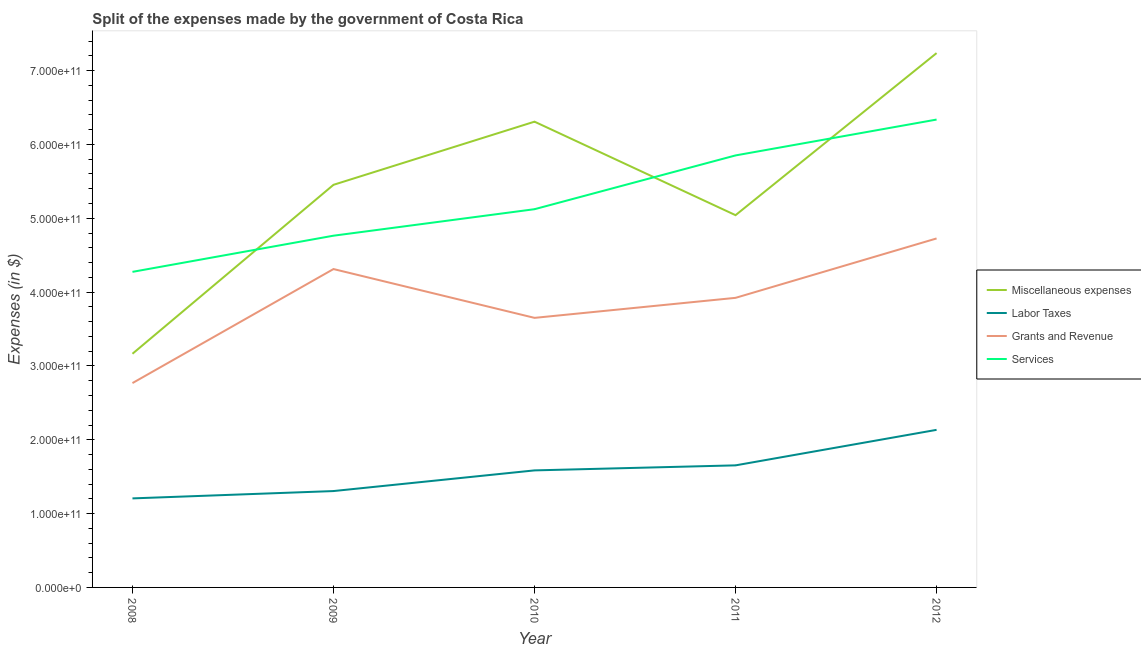How many different coloured lines are there?
Make the answer very short. 4. Is the number of lines equal to the number of legend labels?
Give a very brief answer. Yes. What is the amount spent on grants and revenue in 2012?
Your response must be concise. 4.73e+11. Across all years, what is the maximum amount spent on grants and revenue?
Your answer should be compact. 4.73e+11. Across all years, what is the minimum amount spent on labor taxes?
Offer a terse response. 1.21e+11. In which year was the amount spent on miscellaneous expenses minimum?
Provide a short and direct response. 2008. What is the total amount spent on grants and revenue in the graph?
Offer a terse response. 1.94e+12. What is the difference between the amount spent on miscellaneous expenses in 2011 and that in 2012?
Your answer should be compact. -2.20e+11. What is the difference between the amount spent on labor taxes in 2012 and the amount spent on services in 2010?
Your answer should be compact. -2.99e+11. What is the average amount spent on labor taxes per year?
Ensure brevity in your answer.  1.58e+11. In the year 2008, what is the difference between the amount spent on grants and revenue and amount spent on services?
Ensure brevity in your answer.  -1.51e+11. In how many years, is the amount spent on services greater than 500000000000 $?
Offer a very short reply. 3. What is the ratio of the amount spent on services in 2009 to that in 2011?
Keep it short and to the point. 0.81. Is the amount spent on services in 2009 less than that in 2010?
Offer a terse response. Yes. Is the difference between the amount spent on miscellaneous expenses in 2010 and 2012 greater than the difference between the amount spent on services in 2010 and 2012?
Offer a terse response. Yes. What is the difference between the highest and the second highest amount spent on services?
Provide a succinct answer. 4.86e+1. What is the difference between the highest and the lowest amount spent on services?
Keep it short and to the point. 2.06e+11. In how many years, is the amount spent on miscellaneous expenses greater than the average amount spent on miscellaneous expenses taken over all years?
Provide a short and direct response. 3. Is it the case that in every year, the sum of the amount spent on miscellaneous expenses and amount spent on labor taxes is greater than the amount spent on grants and revenue?
Provide a succinct answer. Yes. Is the amount spent on miscellaneous expenses strictly greater than the amount spent on grants and revenue over the years?
Offer a terse response. Yes. Is the amount spent on miscellaneous expenses strictly less than the amount spent on grants and revenue over the years?
Your answer should be very brief. No. How many lines are there?
Provide a succinct answer. 4. How many years are there in the graph?
Ensure brevity in your answer.  5. What is the difference between two consecutive major ticks on the Y-axis?
Make the answer very short. 1.00e+11. Does the graph contain any zero values?
Provide a short and direct response. No. Does the graph contain grids?
Provide a short and direct response. No. How are the legend labels stacked?
Your answer should be compact. Vertical. What is the title of the graph?
Your answer should be compact. Split of the expenses made by the government of Costa Rica. Does "HFC gas" appear as one of the legend labels in the graph?
Offer a terse response. No. What is the label or title of the Y-axis?
Provide a succinct answer. Expenses (in $). What is the Expenses (in $) in Miscellaneous expenses in 2008?
Your answer should be very brief. 3.16e+11. What is the Expenses (in $) of Labor Taxes in 2008?
Give a very brief answer. 1.21e+11. What is the Expenses (in $) in Grants and Revenue in 2008?
Keep it short and to the point. 2.77e+11. What is the Expenses (in $) in Services in 2008?
Provide a succinct answer. 4.27e+11. What is the Expenses (in $) in Miscellaneous expenses in 2009?
Provide a short and direct response. 5.45e+11. What is the Expenses (in $) of Labor Taxes in 2009?
Keep it short and to the point. 1.31e+11. What is the Expenses (in $) of Grants and Revenue in 2009?
Give a very brief answer. 4.31e+11. What is the Expenses (in $) of Services in 2009?
Your response must be concise. 4.76e+11. What is the Expenses (in $) in Miscellaneous expenses in 2010?
Make the answer very short. 6.31e+11. What is the Expenses (in $) of Labor Taxes in 2010?
Your response must be concise. 1.59e+11. What is the Expenses (in $) in Grants and Revenue in 2010?
Ensure brevity in your answer.  3.65e+11. What is the Expenses (in $) of Services in 2010?
Your answer should be very brief. 5.12e+11. What is the Expenses (in $) of Miscellaneous expenses in 2011?
Your answer should be compact. 5.04e+11. What is the Expenses (in $) of Labor Taxes in 2011?
Your answer should be very brief. 1.65e+11. What is the Expenses (in $) in Grants and Revenue in 2011?
Your answer should be very brief. 3.92e+11. What is the Expenses (in $) of Services in 2011?
Give a very brief answer. 5.85e+11. What is the Expenses (in $) in Miscellaneous expenses in 2012?
Ensure brevity in your answer.  7.24e+11. What is the Expenses (in $) in Labor Taxes in 2012?
Your response must be concise. 2.13e+11. What is the Expenses (in $) of Grants and Revenue in 2012?
Your answer should be compact. 4.73e+11. What is the Expenses (in $) of Services in 2012?
Give a very brief answer. 6.34e+11. Across all years, what is the maximum Expenses (in $) in Miscellaneous expenses?
Provide a short and direct response. 7.24e+11. Across all years, what is the maximum Expenses (in $) of Labor Taxes?
Your response must be concise. 2.13e+11. Across all years, what is the maximum Expenses (in $) of Grants and Revenue?
Your answer should be very brief. 4.73e+11. Across all years, what is the maximum Expenses (in $) of Services?
Give a very brief answer. 6.34e+11. Across all years, what is the minimum Expenses (in $) in Miscellaneous expenses?
Ensure brevity in your answer.  3.16e+11. Across all years, what is the minimum Expenses (in $) in Labor Taxes?
Provide a short and direct response. 1.21e+11. Across all years, what is the minimum Expenses (in $) in Grants and Revenue?
Offer a very short reply. 2.77e+11. Across all years, what is the minimum Expenses (in $) in Services?
Offer a terse response. 4.27e+11. What is the total Expenses (in $) in Miscellaneous expenses in the graph?
Your answer should be very brief. 2.72e+12. What is the total Expenses (in $) of Labor Taxes in the graph?
Make the answer very short. 7.88e+11. What is the total Expenses (in $) in Grants and Revenue in the graph?
Offer a very short reply. 1.94e+12. What is the total Expenses (in $) in Services in the graph?
Keep it short and to the point. 2.63e+12. What is the difference between the Expenses (in $) of Miscellaneous expenses in 2008 and that in 2009?
Offer a very short reply. -2.29e+11. What is the difference between the Expenses (in $) in Labor Taxes in 2008 and that in 2009?
Keep it short and to the point. -9.94e+09. What is the difference between the Expenses (in $) in Grants and Revenue in 2008 and that in 2009?
Offer a terse response. -1.54e+11. What is the difference between the Expenses (in $) of Services in 2008 and that in 2009?
Your answer should be very brief. -4.90e+1. What is the difference between the Expenses (in $) of Miscellaneous expenses in 2008 and that in 2010?
Provide a short and direct response. -3.14e+11. What is the difference between the Expenses (in $) of Labor Taxes in 2008 and that in 2010?
Your answer should be compact. -3.79e+1. What is the difference between the Expenses (in $) of Grants and Revenue in 2008 and that in 2010?
Your response must be concise. -8.83e+1. What is the difference between the Expenses (in $) in Services in 2008 and that in 2010?
Offer a very short reply. -8.49e+1. What is the difference between the Expenses (in $) in Miscellaneous expenses in 2008 and that in 2011?
Make the answer very short. -1.88e+11. What is the difference between the Expenses (in $) of Labor Taxes in 2008 and that in 2011?
Provide a succinct answer. -4.47e+1. What is the difference between the Expenses (in $) in Grants and Revenue in 2008 and that in 2011?
Your answer should be very brief. -1.15e+11. What is the difference between the Expenses (in $) in Services in 2008 and that in 2011?
Give a very brief answer. -1.58e+11. What is the difference between the Expenses (in $) of Miscellaneous expenses in 2008 and that in 2012?
Give a very brief answer. -4.07e+11. What is the difference between the Expenses (in $) in Labor Taxes in 2008 and that in 2012?
Your response must be concise. -9.28e+1. What is the difference between the Expenses (in $) in Grants and Revenue in 2008 and that in 2012?
Your answer should be very brief. -1.96e+11. What is the difference between the Expenses (in $) of Services in 2008 and that in 2012?
Ensure brevity in your answer.  -2.06e+11. What is the difference between the Expenses (in $) of Miscellaneous expenses in 2009 and that in 2010?
Keep it short and to the point. -8.55e+1. What is the difference between the Expenses (in $) of Labor Taxes in 2009 and that in 2010?
Provide a succinct answer. -2.80e+1. What is the difference between the Expenses (in $) of Grants and Revenue in 2009 and that in 2010?
Offer a terse response. 6.61e+1. What is the difference between the Expenses (in $) in Services in 2009 and that in 2010?
Offer a terse response. -3.59e+1. What is the difference between the Expenses (in $) in Miscellaneous expenses in 2009 and that in 2011?
Offer a very short reply. 4.11e+1. What is the difference between the Expenses (in $) of Labor Taxes in 2009 and that in 2011?
Keep it short and to the point. -3.48e+1. What is the difference between the Expenses (in $) in Grants and Revenue in 2009 and that in 2011?
Provide a short and direct response. 3.90e+1. What is the difference between the Expenses (in $) of Services in 2009 and that in 2011?
Provide a short and direct response. -1.09e+11. What is the difference between the Expenses (in $) of Miscellaneous expenses in 2009 and that in 2012?
Make the answer very short. -1.78e+11. What is the difference between the Expenses (in $) of Labor Taxes in 2009 and that in 2012?
Provide a succinct answer. -8.29e+1. What is the difference between the Expenses (in $) in Grants and Revenue in 2009 and that in 2012?
Your response must be concise. -4.15e+1. What is the difference between the Expenses (in $) in Services in 2009 and that in 2012?
Offer a terse response. -1.57e+11. What is the difference between the Expenses (in $) in Miscellaneous expenses in 2010 and that in 2011?
Make the answer very short. 1.27e+11. What is the difference between the Expenses (in $) of Labor Taxes in 2010 and that in 2011?
Ensure brevity in your answer.  -6.81e+09. What is the difference between the Expenses (in $) of Grants and Revenue in 2010 and that in 2011?
Your response must be concise. -2.71e+1. What is the difference between the Expenses (in $) of Services in 2010 and that in 2011?
Offer a very short reply. -7.28e+1. What is the difference between the Expenses (in $) in Miscellaneous expenses in 2010 and that in 2012?
Keep it short and to the point. -9.29e+1. What is the difference between the Expenses (in $) of Labor Taxes in 2010 and that in 2012?
Offer a terse response. -5.49e+1. What is the difference between the Expenses (in $) in Grants and Revenue in 2010 and that in 2012?
Your response must be concise. -1.08e+11. What is the difference between the Expenses (in $) of Services in 2010 and that in 2012?
Give a very brief answer. -1.21e+11. What is the difference between the Expenses (in $) in Miscellaneous expenses in 2011 and that in 2012?
Offer a terse response. -2.20e+11. What is the difference between the Expenses (in $) in Labor Taxes in 2011 and that in 2012?
Make the answer very short. -4.81e+1. What is the difference between the Expenses (in $) of Grants and Revenue in 2011 and that in 2012?
Your answer should be compact. -8.04e+1. What is the difference between the Expenses (in $) in Services in 2011 and that in 2012?
Give a very brief answer. -4.86e+1. What is the difference between the Expenses (in $) in Miscellaneous expenses in 2008 and the Expenses (in $) in Labor Taxes in 2009?
Your answer should be compact. 1.86e+11. What is the difference between the Expenses (in $) in Miscellaneous expenses in 2008 and the Expenses (in $) in Grants and Revenue in 2009?
Your answer should be compact. -1.15e+11. What is the difference between the Expenses (in $) in Miscellaneous expenses in 2008 and the Expenses (in $) in Services in 2009?
Make the answer very short. -1.60e+11. What is the difference between the Expenses (in $) of Labor Taxes in 2008 and the Expenses (in $) of Grants and Revenue in 2009?
Give a very brief answer. -3.11e+11. What is the difference between the Expenses (in $) in Labor Taxes in 2008 and the Expenses (in $) in Services in 2009?
Provide a short and direct response. -3.56e+11. What is the difference between the Expenses (in $) in Grants and Revenue in 2008 and the Expenses (in $) in Services in 2009?
Offer a terse response. -2.00e+11. What is the difference between the Expenses (in $) of Miscellaneous expenses in 2008 and the Expenses (in $) of Labor Taxes in 2010?
Your answer should be very brief. 1.58e+11. What is the difference between the Expenses (in $) of Miscellaneous expenses in 2008 and the Expenses (in $) of Grants and Revenue in 2010?
Keep it short and to the point. -4.86e+1. What is the difference between the Expenses (in $) of Miscellaneous expenses in 2008 and the Expenses (in $) of Services in 2010?
Offer a very short reply. -1.96e+11. What is the difference between the Expenses (in $) in Labor Taxes in 2008 and the Expenses (in $) in Grants and Revenue in 2010?
Your response must be concise. -2.45e+11. What is the difference between the Expenses (in $) in Labor Taxes in 2008 and the Expenses (in $) in Services in 2010?
Your answer should be compact. -3.92e+11. What is the difference between the Expenses (in $) of Grants and Revenue in 2008 and the Expenses (in $) of Services in 2010?
Offer a very short reply. -2.36e+11. What is the difference between the Expenses (in $) of Miscellaneous expenses in 2008 and the Expenses (in $) of Labor Taxes in 2011?
Give a very brief answer. 1.51e+11. What is the difference between the Expenses (in $) in Miscellaneous expenses in 2008 and the Expenses (in $) in Grants and Revenue in 2011?
Provide a short and direct response. -7.57e+1. What is the difference between the Expenses (in $) of Miscellaneous expenses in 2008 and the Expenses (in $) of Services in 2011?
Your answer should be very brief. -2.69e+11. What is the difference between the Expenses (in $) in Labor Taxes in 2008 and the Expenses (in $) in Grants and Revenue in 2011?
Offer a terse response. -2.72e+11. What is the difference between the Expenses (in $) of Labor Taxes in 2008 and the Expenses (in $) of Services in 2011?
Provide a succinct answer. -4.65e+11. What is the difference between the Expenses (in $) of Grants and Revenue in 2008 and the Expenses (in $) of Services in 2011?
Provide a short and direct response. -3.08e+11. What is the difference between the Expenses (in $) of Miscellaneous expenses in 2008 and the Expenses (in $) of Labor Taxes in 2012?
Offer a very short reply. 1.03e+11. What is the difference between the Expenses (in $) of Miscellaneous expenses in 2008 and the Expenses (in $) of Grants and Revenue in 2012?
Give a very brief answer. -1.56e+11. What is the difference between the Expenses (in $) in Miscellaneous expenses in 2008 and the Expenses (in $) in Services in 2012?
Offer a very short reply. -3.17e+11. What is the difference between the Expenses (in $) in Labor Taxes in 2008 and the Expenses (in $) in Grants and Revenue in 2012?
Keep it short and to the point. -3.52e+11. What is the difference between the Expenses (in $) in Labor Taxes in 2008 and the Expenses (in $) in Services in 2012?
Make the answer very short. -5.13e+11. What is the difference between the Expenses (in $) of Grants and Revenue in 2008 and the Expenses (in $) of Services in 2012?
Provide a succinct answer. -3.57e+11. What is the difference between the Expenses (in $) in Miscellaneous expenses in 2009 and the Expenses (in $) in Labor Taxes in 2010?
Provide a succinct answer. 3.87e+11. What is the difference between the Expenses (in $) of Miscellaneous expenses in 2009 and the Expenses (in $) of Grants and Revenue in 2010?
Your response must be concise. 1.80e+11. What is the difference between the Expenses (in $) of Miscellaneous expenses in 2009 and the Expenses (in $) of Services in 2010?
Provide a short and direct response. 3.30e+1. What is the difference between the Expenses (in $) of Labor Taxes in 2009 and the Expenses (in $) of Grants and Revenue in 2010?
Your answer should be very brief. -2.35e+11. What is the difference between the Expenses (in $) in Labor Taxes in 2009 and the Expenses (in $) in Services in 2010?
Make the answer very short. -3.82e+11. What is the difference between the Expenses (in $) in Grants and Revenue in 2009 and the Expenses (in $) in Services in 2010?
Provide a succinct answer. -8.11e+1. What is the difference between the Expenses (in $) in Miscellaneous expenses in 2009 and the Expenses (in $) in Labor Taxes in 2011?
Offer a terse response. 3.80e+11. What is the difference between the Expenses (in $) of Miscellaneous expenses in 2009 and the Expenses (in $) of Grants and Revenue in 2011?
Your answer should be very brief. 1.53e+11. What is the difference between the Expenses (in $) in Miscellaneous expenses in 2009 and the Expenses (in $) in Services in 2011?
Ensure brevity in your answer.  -3.98e+1. What is the difference between the Expenses (in $) of Labor Taxes in 2009 and the Expenses (in $) of Grants and Revenue in 2011?
Provide a succinct answer. -2.62e+11. What is the difference between the Expenses (in $) in Labor Taxes in 2009 and the Expenses (in $) in Services in 2011?
Keep it short and to the point. -4.55e+11. What is the difference between the Expenses (in $) in Grants and Revenue in 2009 and the Expenses (in $) in Services in 2011?
Provide a short and direct response. -1.54e+11. What is the difference between the Expenses (in $) in Miscellaneous expenses in 2009 and the Expenses (in $) in Labor Taxes in 2012?
Your response must be concise. 3.32e+11. What is the difference between the Expenses (in $) in Miscellaneous expenses in 2009 and the Expenses (in $) in Grants and Revenue in 2012?
Offer a very short reply. 7.27e+1. What is the difference between the Expenses (in $) in Miscellaneous expenses in 2009 and the Expenses (in $) in Services in 2012?
Ensure brevity in your answer.  -8.84e+1. What is the difference between the Expenses (in $) in Labor Taxes in 2009 and the Expenses (in $) in Grants and Revenue in 2012?
Provide a short and direct response. -3.42e+11. What is the difference between the Expenses (in $) in Labor Taxes in 2009 and the Expenses (in $) in Services in 2012?
Offer a terse response. -5.03e+11. What is the difference between the Expenses (in $) of Grants and Revenue in 2009 and the Expenses (in $) of Services in 2012?
Your answer should be compact. -2.02e+11. What is the difference between the Expenses (in $) of Miscellaneous expenses in 2010 and the Expenses (in $) of Labor Taxes in 2011?
Ensure brevity in your answer.  4.66e+11. What is the difference between the Expenses (in $) of Miscellaneous expenses in 2010 and the Expenses (in $) of Grants and Revenue in 2011?
Your answer should be compact. 2.39e+11. What is the difference between the Expenses (in $) in Miscellaneous expenses in 2010 and the Expenses (in $) in Services in 2011?
Ensure brevity in your answer.  4.57e+1. What is the difference between the Expenses (in $) in Labor Taxes in 2010 and the Expenses (in $) in Grants and Revenue in 2011?
Offer a terse response. -2.34e+11. What is the difference between the Expenses (in $) in Labor Taxes in 2010 and the Expenses (in $) in Services in 2011?
Make the answer very short. -4.27e+11. What is the difference between the Expenses (in $) in Grants and Revenue in 2010 and the Expenses (in $) in Services in 2011?
Offer a terse response. -2.20e+11. What is the difference between the Expenses (in $) of Miscellaneous expenses in 2010 and the Expenses (in $) of Labor Taxes in 2012?
Keep it short and to the point. 4.17e+11. What is the difference between the Expenses (in $) of Miscellaneous expenses in 2010 and the Expenses (in $) of Grants and Revenue in 2012?
Your response must be concise. 1.58e+11. What is the difference between the Expenses (in $) in Miscellaneous expenses in 2010 and the Expenses (in $) in Services in 2012?
Your response must be concise. -2.85e+09. What is the difference between the Expenses (in $) of Labor Taxes in 2010 and the Expenses (in $) of Grants and Revenue in 2012?
Give a very brief answer. -3.14e+11. What is the difference between the Expenses (in $) of Labor Taxes in 2010 and the Expenses (in $) of Services in 2012?
Offer a terse response. -4.75e+11. What is the difference between the Expenses (in $) in Grants and Revenue in 2010 and the Expenses (in $) in Services in 2012?
Your answer should be compact. -2.69e+11. What is the difference between the Expenses (in $) of Miscellaneous expenses in 2011 and the Expenses (in $) of Labor Taxes in 2012?
Your answer should be very brief. 2.91e+11. What is the difference between the Expenses (in $) of Miscellaneous expenses in 2011 and the Expenses (in $) of Grants and Revenue in 2012?
Ensure brevity in your answer.  3.15e+1. What is the difference between the Expenses (in $) of Miscellaneous expenses in 2011 and the Expenses (in $) of Services in 2012?
Offer a very short reply. -1.29e+11. What is the difference between the Expenses (in $) in Labor Taxes in 2011 and the Expenses (in $) in Grants and Revenue in 2012?
Provide a short and direct response. -3.07e+11. What is the difference between the Expenses (in $) in Labor Taxes in 2011 and the Expenses (in $) in Services in 2012?
Keep it short and to the point. -4.68e+11. What is the difference between the Expenses (in $) of Grants and Revenue in 2011 and the Expenses (in $) of Services in 2012?
Offer a very short reply. -2.41e+11. What is the average Expenses (in $) of Miscellaneous expenses per year?
Give a very brief answer. 5.44e+11. What is the average Expenses (in $) of Labor Taxes per year?
Offer a very short reply. 1.58e+11. What is the average Expenses (in $) of Grants and Revenue per year?
Your response must be concise. 3.88e+11. What is the average Expenses (in $) in Services per year?
Make the answer very short. 5.27e+11. In the year 2008, what is the difference between the Expenses (in $) in Miscellaneous expenses and Expenses (in $) in Labor Taxes?
Make the answer very short. 1.96e+11. In the year 2008, what is the difference between the Expenses (in $) in Miscellaneous expenses and Expenses (in $) in Grants and Revenue?
Give a very brief answer. 3.97e+1. In the year 2008, what is the difference between the Expenses (in $) in Miscellaneous expenses and Expenses (in $) in Services?
Offer a terse response. -1.11e+11. In the year 2008, what is the difference between the Expenses (in $) in Labor Taxes and Expenses (in $) in Grants and Revenue?
Your answer should be very brief. -1.56e+11. In the year 2008, what is the difference between the Expenses (in $) in Labor Taxes and Expenses (in $) in Services?
Your answer should be compact. -3.07e+11. In the year 2008, what is the difference between the Expenses (in $) of Grants and Revenue and Expenses (in $) of Services?
Your response must be concise. -1.51e+11. In the year 2009, what is the difference between the Expenses (in $) of Miscellaneous expenses and Expenses (in $) of Labor Taxes?
Provide a succinct answer. 4.15e+11. In the year 2009, what is the difference between the Expenses (in $) in Miscellaneous expenses and Expenses (in $) in Grants and Revenue?
Offer a very short reply. 1.14e+11. In the year 2009, what is the difference between the Expenses (in $) of Miscellaneous expenses and Expenses (in $) of Services?
Keep it short and to the point. 6.89e+1. In the year 2009, what is the difference between the Expenses (in $) in Labor Taxes and Expenses (in $) in Grants and Revenue?
Your answer should be compact. -3.01e+11. In the year 2009, what is the difference between the Expenses (in $) of Labor Taxes and Expenses (in $) of Services?
Your response must be concise. -3.46e+11. In the year 2009, what is the difference between the Expenses (in $) of Grants and Revenue and Expenses (in $) of Services?
Your answer should be very brief. -4.52e+1. In the year 2010, what is the difference between the Expenses (in $) in Miscellaneous expenses and Expenses (in $) in Labor Taxes?
Your answer should be very brief. 4.72e+11. In the year 2010, what is the difference between the Expenses (in $) of Miscellaneous expenses and Expenses (in $) of Grants and Revenue?
Make the answer very short. 2.66e+11. In the year 2010, what is the difference between the Expenses (in $) of Miscellaneous expenses and Expenses (in $) of Services?
Provide a succinct answer. 1.19e+11. In the year 2010, what is the difference between the Expenses (in $) of Labor Taxes and Expenses (in $) of Grants and Revenue?
Your answer should be very brief. -2.07e+11. In the year 2010, what is the difference between the Expenses (in $) of Labor Taxes and Expenses (in $) of Services?
Make the answer very short. -3.54e+11. In the year 2010, what is the difference between the Expenses (in $) in Grants and Revenue and Expenses (in $) in Services?
Keep it short and to the point. -1.47e+11. In the year 2011, what is the difference between the Expenses (in $) in Miscellaneous expenses and Expenses (in $) in Labor Taxes?
Your response must be concise. 3.39e+11. In the year 2011, what is the difference between the Expenses (in $) of Miscellaneous expenses and Expenses (in $) of Grants and Revenue?
Provide a succinct answer. 1.12e+11. In the year 2011, what is the difference between the Expenses (in $) in Miscellaneous expenses and Expenses (in $) in Services?
Offer a very short reply. -8.09e+1. In the year 2011, what is the difference between the Expenses (in $) in Labor Taxes and Expenses (in $) in Grants and Revenue?
Your answer should be very brief. -2.27e+11. In the year 2011, what is the difference between the Expenses (in $) of Labor Taxes and Expenses (in $) of Services?
Your answer should be very brief. -4.20e+11. In the year 2011, what is the difference between the Expenses (in $) in Grants and Revenue and Expenses (in $) in Services?
Offer a terse response. -1.93e+11. In the year 2012, what is the difference between the Expenses (in $) in Miscellaneous expenses and Expenses (in $) in Labor Taxes?
Provide a short and direct response. 5.10e+11. In the year 2012, what is the difference between the Expenses (in $) in Miscellaneous expenses and Expenses (in $) in Grants and Revenue?
Your response must be concise. 2.51e+11. In the year 2012, what is the difference between the Expenses (in $) in Miscellaneous expenses and Expenses (in $) in Services?
Make the answer very short. 9.00e+1. In the year 2012, what is the difference between the Expenses (in $) of Labor Taxes and Expenses (in $) of Grants and Revenue?
Make the answer very short. -2.59e+11. In the year 2012, what is the difference between the Expenses (in $) in Labor Taxes and Expenses (in $) in Services?
Provide a short and direct response. -4.20e+11. In the year 2012, what is the difference between the Expenses (in $) of Grants and Revenue and Expenses (in $) of Services?
Offer a terse response. -1.61e+11. What is the ratio of the Expenses (in $) in Miscellaneous expenses in 2008 to that in 2009?
Provide a short and direct response. 0.58. What is the ratio of the Expenses (in $) of Labor Taxes in 2008 to that in 2009?
Keep it short and to the point. 0.92. What is the ratio of the Expenses (in $) of Grants and Revenue in 2008 to that in 2009?
Offer a terse response. 0.64. What is the ratio of the Expenses (in $) in Services in 2008 to that in 2009?
Your response must be concise. 0.9. What is the ratio of the Expenses (in $) in Miscellaneous expenses in 2008 to that in 2010?
Offer a terse response. 0.5. What is the ratio of the Expenses (in $) in Labor Taxes in 2008 to that in 2010?
Offer a very short reply. 0.76. What is the ratio of the Expenses (in $) of Grants and Revenue in 2008 to that in 2010?
Your answer should be very brief. 0.76. What is the ratio of the Expenses (in $) of Services in 2008 to that in 2010?
Ensure brevity in your answer.  0.83. What is the ratio of the Expenses (in $) of Miscellaneous expenses in 2008 to that in 2011?
Keep it short and to the point. 0.63. What is the ratio of the Expenses (in $) in Labor Taxes in 2008 to that in 2011?
Keep it short and to the point. 0.73. What is the ratio of the Expenses (in $) of Grants and Revenue in 2008 to that in 2011?
Ensure brevity in your answer.  0.71. What is the ratio of the Expenses (in $) of Services in 2008 to that in 2011?
Provide a short and direct response. 0.73. What is the ratio of the Expenses (in $) of Miscellaneous expenses in 2008 to that in 2012?
Provide a succinct answer. 0.44. What is the ratio of the Expenses (in $) in Labor Taxes in 2008 to that in 2012?
Make the answer very short. 0.56. What is the ratio of the Expenses (in $) in Grants and Revenue in 2008 to that in 2012?
Your answer should be compact. 0.59. What is the ratio of the Expenses (in $) of Services in 2008 to that in 2012?
Your response must be concise. 0.67. What is the ratio of the Expenses (in $) in Miscellaneous expenses in 2009 to that in 2010?
Provide a succinct answer. 0.86. What is the ratio of the Expenses (in $) of Labor Taxes in 2009 to that in 2010?
Give a very brief answer. 0.82. What is the ratio of the Expenses (in $) in Grants and Revenue in 2009 to that in 2010?
Give a very brief answer. 1.18. What is the ratio of the Expenses (in $) of Miscellaneous expenses in 2009 to that in 2011?
Provide a short and direct response. 1.08. What is the ratio of the Expenses (in $) of Labor Taxes in 2009 to that in 2011?
Give a very brief answer. 0.79. What is the ratio of the Expenses (in $) of Grants and Revenue in 2009 to that in 2011?
Give a very brief answer. 1.1. What is the ratio of the Expenses (in $) of Services in 2009 to that in 2011?
Give a very brief answer. 0.81. What is the ratio of the Expenses (in $) of Miscellaneous expenses in 2009 to that in 2012?
Give a very brief answer. 0.75. What is the ratio of the Expenses (in $) in Labor Taxes in 2009 to that in 2012?
Provide a short and direct response. 0.61. What is the ratio of the Expenses (in $) of Grants and Revenue in 2009 to that in 2012?
Make the answer very short. 0.91. What is the ratio of the Expenses (in $) of Services in 2009 to that in 2012?
Keep it short and to the point. 0.75. What is the ratio of the Expenses (in $) of Miscellaneous expenses in 2010 to that in 2011?
Ensure brevity in your answer.  1.25. What is the ratio of the Expenses (in $) in Labor Taxes in 2010 to that in 2011?
Ensure brevity in your answer.  0.96. What is the ratio of the Expenses (in $) of Grants and Revenue in 2010 to that in 2011?
Your response must be concise. 0.93. What is the ratio of the Expenses (in $) of Services in 2010 to that in 2011?
Your answer should be compact. 0.88. What is the ratio of the Expenses (in $) in Miscellaneous expenses in 2010 to that in 2012?
Provide a short and direct response. 0.87. What is the ratio of the Expenses (in $) in Labor Taxes in 2010 to that in 2012?
Keep it short and to the point. 0.74. What is the ratio of the Expenses (in $) of Grants and Revenue in 2010 to that in 2012?
Provide a succinct answer. 0.77. What is the ratio of the Expenses (in $) of Services in 2010 to that in 2012?
Give a very brief answer. 0.81. What is the ratio of the Expenses (in $) of Miscellaneous expenses in 2011 to that in 2012?
Offer a terse response. 0.7. What is the ratio of the Expenses (in $) of Labor Taxes in 2011 to that in 2012?
Your response must be concise. 0.77. What is the ratio of the Expenses (in $) in Grants and Revenue in 2011 to that in 2012?
Keep it short and to the point. 0.83. What is the ratio of the Expenses (in $) of Services in 2011 to that in 2012?
Your answer should be very brief. 0.92. What is the difference between the highest and the second highest Expenses (in $) of Miscellaneous expenses?
Your response must be concise. 9.29e+1. What is the difference between the highest and the second highest Expenses (in $) in Labor Taxes?
Ensure brevity in your answer.  4.81e+1. What is the difference between the highest and the second highest Expenses (in $) in Grants and Revenue?
Your answer should be very brief. 4.15e+1. What is the difference between the highest and the second highest Expenses (in $) in Services?
Keep it short and to the point. 4.86e+1. What is the difference between the highest and the lowest Expenses (in $) of Miscellaneous expenses?
Your response must be concise. 4.07e+11. What is the difference between the highest and the lowest Expenses (in $) in Labor Taxes?
Give a very brief answer. 9.28e+1. What is the difference between the highest and the lowest Expenses (in $) of Grants and Revenue?
Offer a terse response. 1.96e+11. What is the difference between the highest and the lowest Expenses (in $) of Services?
Ensure brevity in your answer.  2.06e+11. 